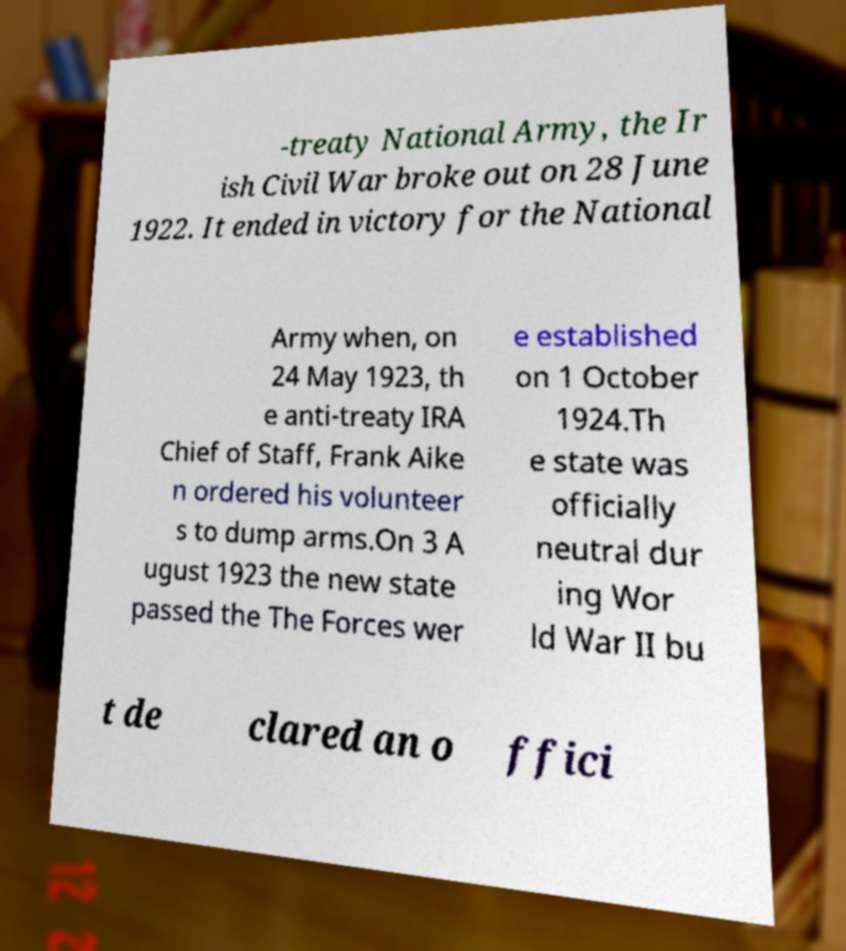Can you read and provide the text displayed in the image?This photo seems to have some interesting text. Can you extract and type it out for me? -treaty National Army, the Ir ish Civil War broke out on 28 June 1922. It ended in victory for the National Army when, on 24 May 1923, th e anti-treaty IRA Chief of Staff, Frank Aike n ordered his volunteer s to dump arms.On 3 A ugust 1923 the new state passed the The Forces wer e established on 1 October 1924.Th e state was officially neutral dur ing Wor ld War II bu t de clared an o ffici 